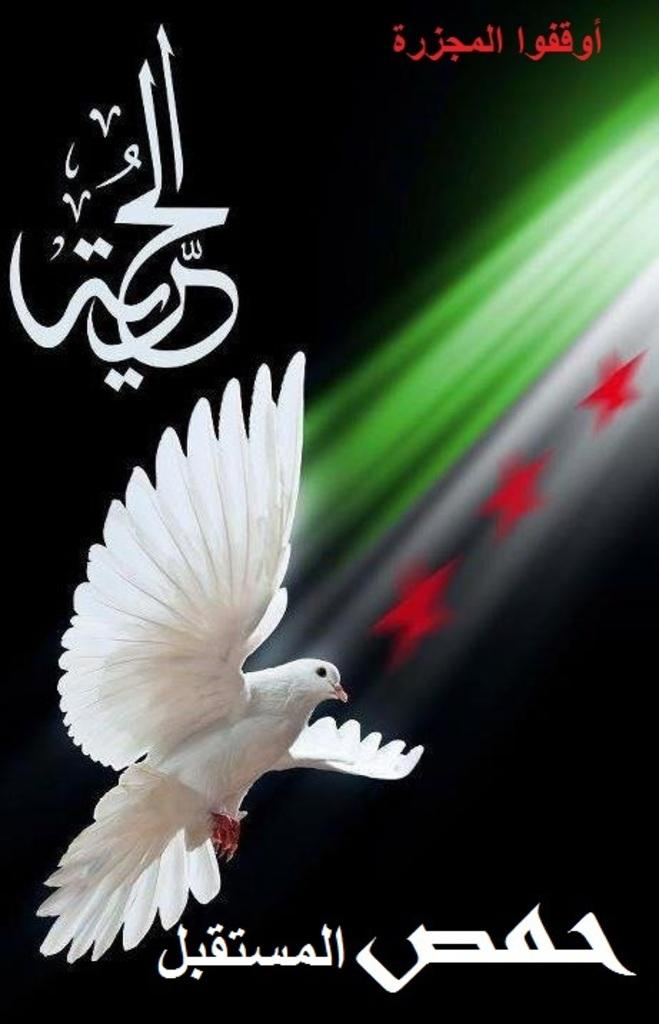What is featured on the poster in the image? There is a poster in the image, and the text on the poster is written in Arabic. Are there any animals visible in the image? Yes, there is a dove bird flying in the image. What type of shapes can be seen in the image? There are three red color stars in the image. What year is depicted on the table in the image? There is no table present in the image, and therefore no year can be depicted on it. Can you describe the beetle crawling on the poster in the image? There is no beetle present in the image; it features a dove bird instead. 